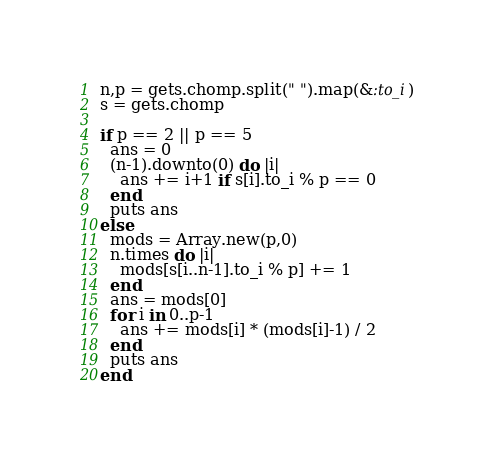Convert code to text. <code><loc_0><loc_0><loc_500><loc_500><_Ruby_>n,p = gets.chomp.split(" ").map(&:to_i)
s = gets.chomp

if p == 2 || p == 5
  ans = 0
  (n-1).downto(0) do |i|
    ans += i+1 if s[i].to_i % p == 0
  end
  puts ans
else
  mods = Array.new(p,0)
  n.times do |i|
    mods[s[i..n-1].to_i % p] += 1
  end
  ans = mods[0]
  for i in 0..p-1
    ans += mods[i] * (mods[i]-1) / 2
  end
  puts ans
end</code> 